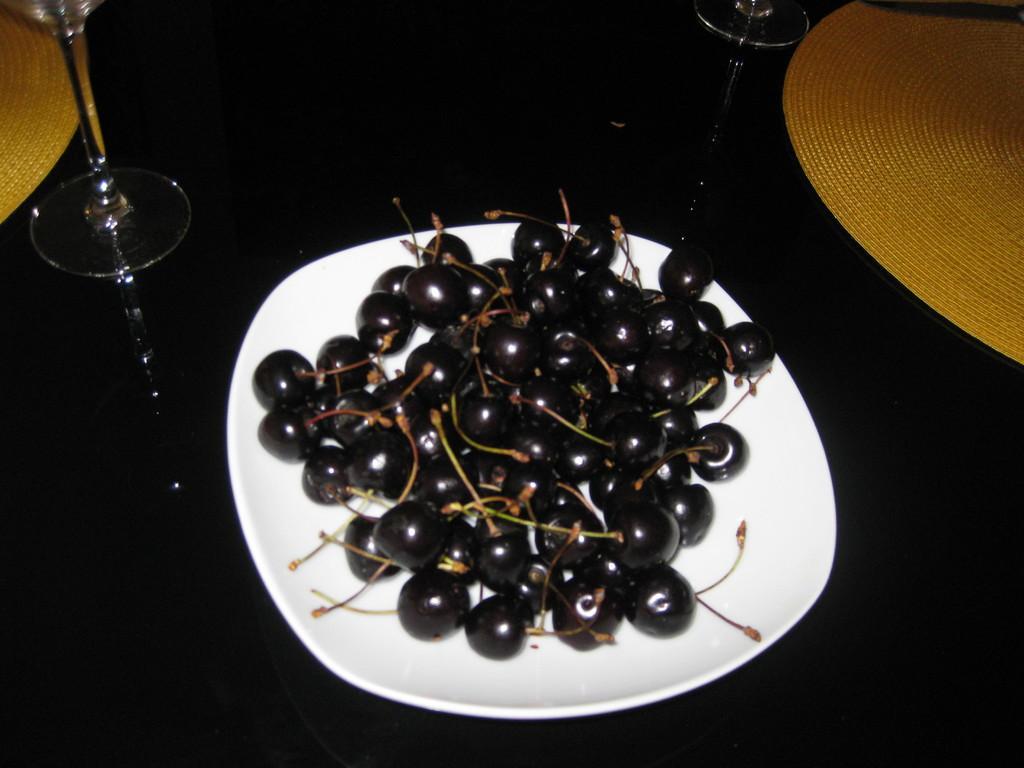How would you summarize this image in a sentence or two? In this picture there is a plate in the center of the image, which contains superfood in it and there are glasses at the top side of the image. 